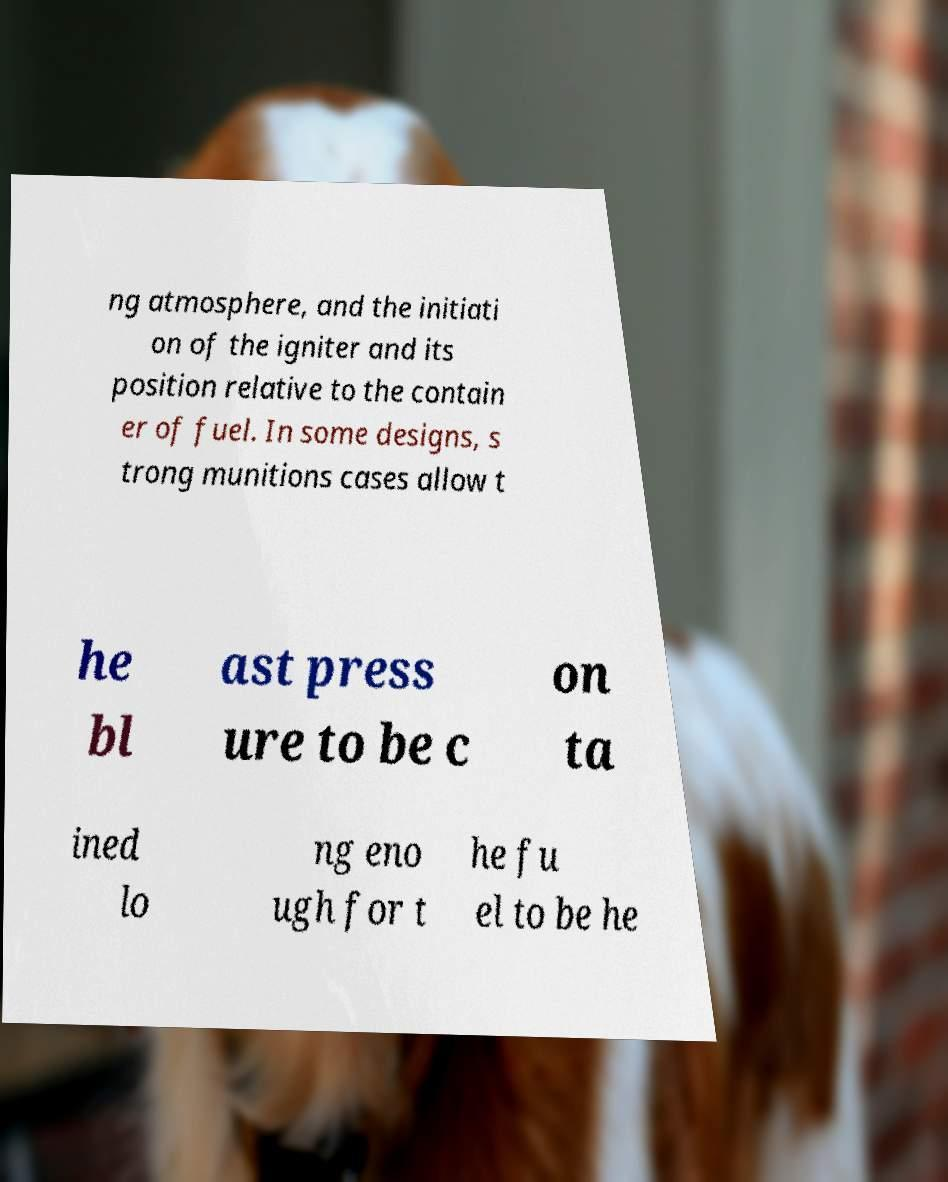Can you accurately transcribe the text from the provided image for me? ng atmosphere, and the initiati on of the igniter and its position relative to the contain er of fuel. In some designs, s trong munitions cases allow t he bl ast press ure to be c on ta ined lo ng eno ugh for t he fu el to be he 